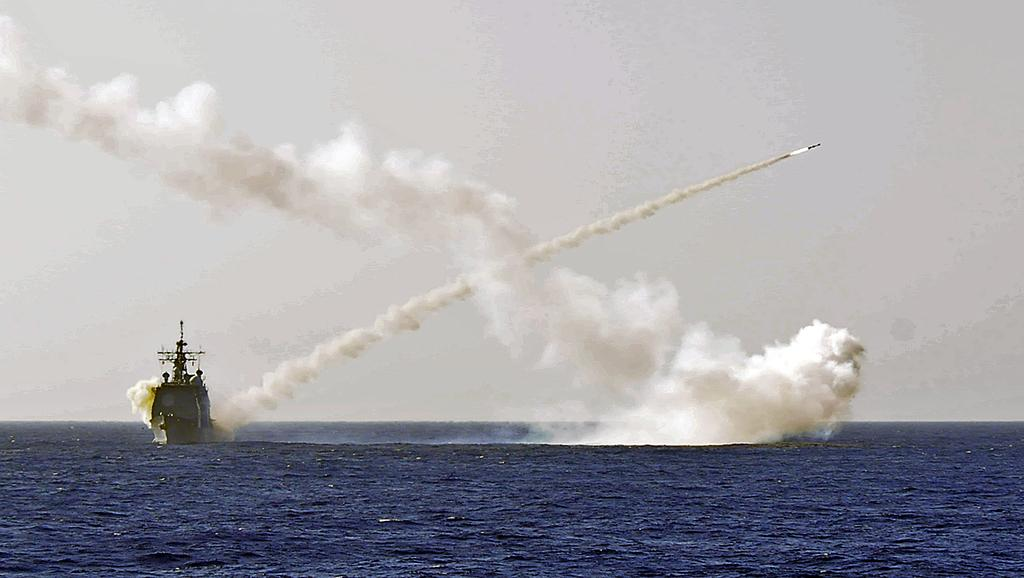What is the main subject of the image? The main subject of the image is a boat. Where is the boat located? The boat is on the water. What else can be seen in the image besides the boat? There is smoke visible in the image. What is visible in the background of the image? The sky is visible in the image. What type of ornament is hanging from the boat's nose in the image? There is no ornament hanging from the boat's nose in the image, as boats do not have noses. 